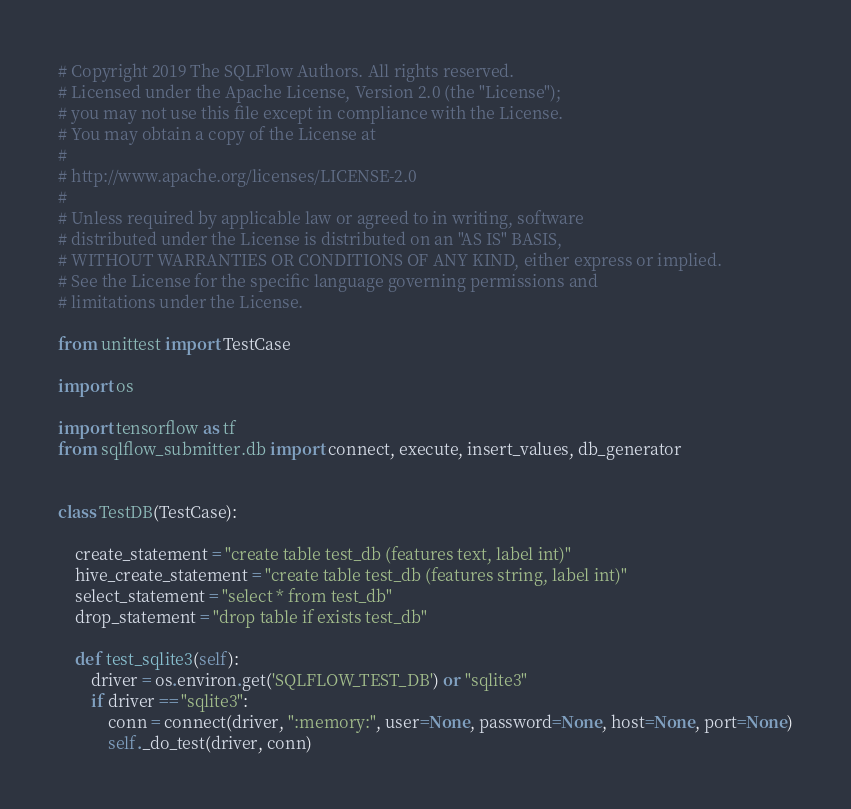Convert code to text. <code><loc_0><loc_0><loc_500><loc_500><_Python_># Copyright 2019 The SQLFlow Authors. All rights reserved.
# Licensed under the Apache License, Version 2.0 (the "License");
# you may not use this file except in compliance with the License.
# You may obtain a copy of the License at
#
# http://www.apache.org/licenses/LICENSE-2.0
#
# Unless required by applicable law or agreed to in writing, software
# distributed under the License is distributed on an "AS IS" BASIS,
# WITHOUT WARRANTIES OR CONDITIONS OF ANY KIND, either express or implied.
# See the License for the specific language governing permissions and
# limitations under the License.

from unittest import TestCase

import os

import tensorflow as tf
from sqlflow_submitter.db import connect, execute, insert_values, db_generator


class TestDB(TestCase):

    create_statement = "create table test_db (features text, label int)"
    hive_create_statement = "create table test_db (features string, label int)"
    select_statement = "select * from test_db"
    drop_statement = "drop table if exists test_db"

    def test_sqlite3(self):
        driver = os.environ.get('SQLFLOW_TEST_DB') or "sqlite3"
        if driver == "sqlite3":
            conn = connect(driver, ":memory:", user=None, password=None, host=None, port=None)
            self._do_test(driver, conn)
</code> 